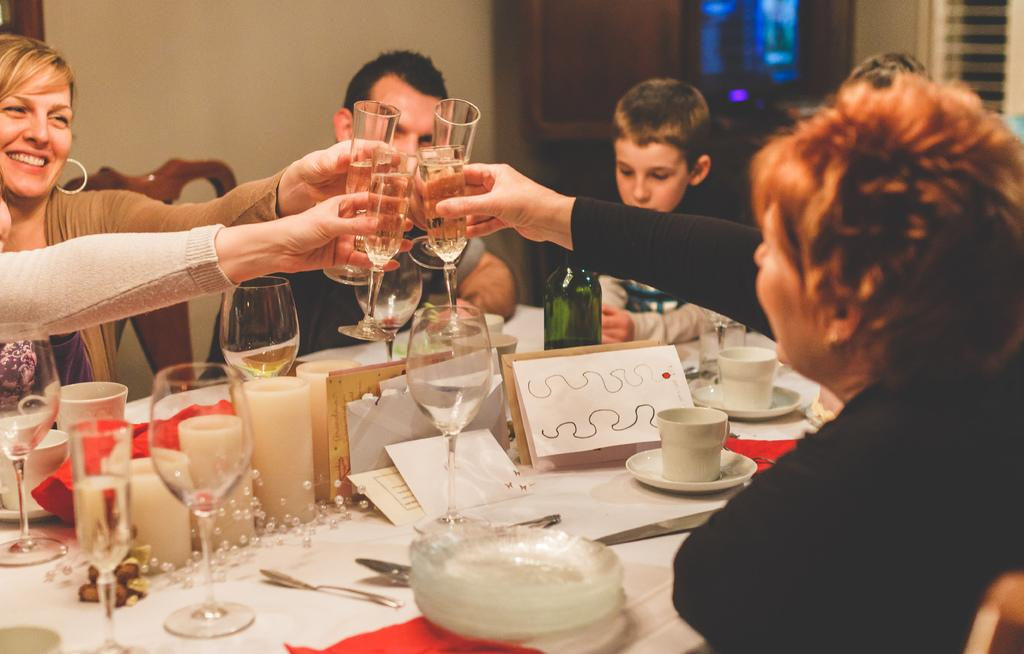How many people are in the image? There are people in the image, but the exact number is not specified. What are the people holding in the image? The people are holding wine glasses in the image. What action are the people taking in the image? The people are taking cheers in the image. What objects can be seen on the table in the image? There are plates, a cup and saucer, knives, spoons, and candles on the table in the image. What is the current temperature in the image? The provided facts do not mention any information about the temperature, so it cannot be determined from the image. How does the feeling of shame manifest in the image? There is no indication of shame or any negative emotions in the image; the people are taking cheers and holding wine glasses. 